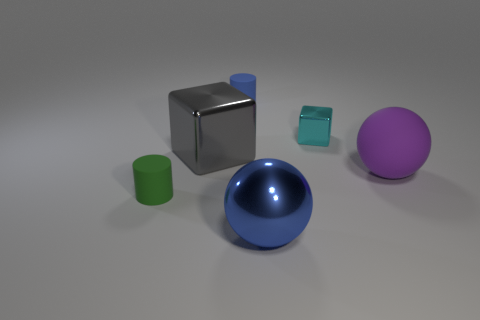Add 4 purple cylinders. How many objects exist? 10 Subtract all cubes. How many objects are left? 4 Add 4 big cyan blocks. How many big cyan blocks exist? 4 Subtract 1 purple spheres. How many objects are left? 5 Subtract all brown objects. Subtract all big purple objects. How many objects are left? 5 Add 4 big metal things. How many big metal things are left? 6 